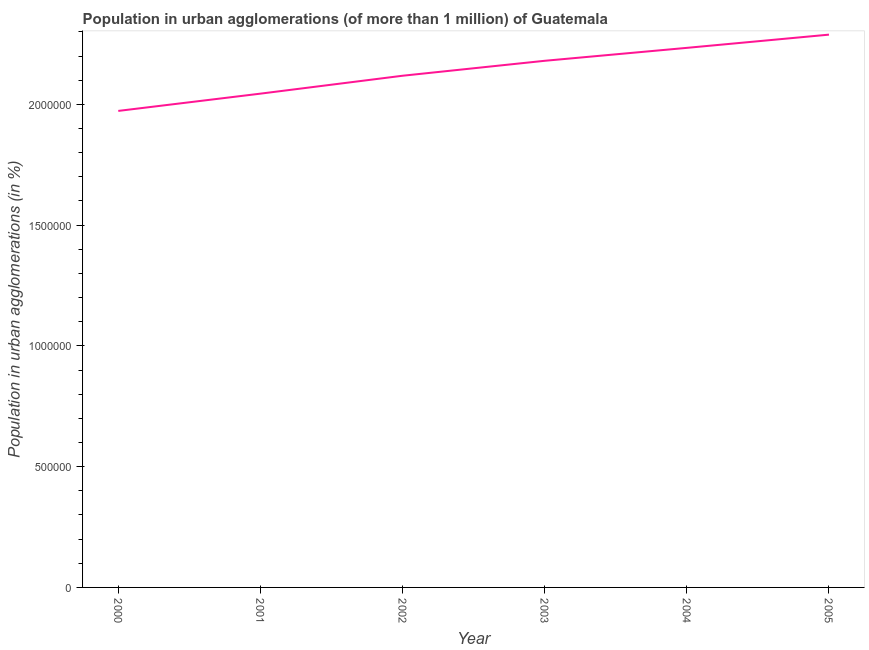What is the population in urban agglomerations in 2001?
Provide a succinct answer. 2.04e+06. Across all years, what is the maximum population in urban agglomerations?
Your answer should be very brief. 2.29e+06. Across all years, what is the minimum population in urban agglomerations?
Provide a short and direct response. 1.97e+06. In which year was the population in urban agglomerations maximum?
Ensure brevity in your answer.  2005. In which year was the population in urban agglomerations minimum?
Keep it short and to the point. 2000. What is the sum of the population in urban agglomerations?
Ensure brevity in your answer.  1.28e+07. What is the difference between the population in urban agglomerations in 2000 and 2004?
Give a very brief answer. -2.61e+05. What is the average population in urban agglomerations per year?
Your answer should be very brief. 2.14e+06. What is the median population in urban agglomerations?
Offer a very short reply. 2.15e+06. What is the ratio of the population in urban agglomerations in 2000 to that in 2004?
Offer a very short reply. 0.88. What is the difference between the highest and the second highest population in urban agglomerations?
Keep it short and to the point. 5.47e+04. Is the sum of the population in urban agglomerations in 2000 and 2001 greater than the maximum population in urban agglomerations across all years?
Offer a terse response. Yes. What is the difference between the highest and the lowest population in urban agglomerations?
Make the answer very short. 3.16e+05. In how many years, is the population in urban agglomerations greater than the average population in urban agglomerations taken over all years?
Offer a terse response. 3. How many lines are there?
Your answer should be compact. 1. How many years are there in the graph?
Your answer should be compact. 6. Does the graph contain any zero values?
Provide a short and direct response. No. Does the graph contain grids?
Give a very brief answer. No. What is the title of the graph?
Offer a terse response. Population in urban agglomerations (of more than 1 million) of Guatemala. What is the label or title of the Y-axis?
Your answer should be compact. Population in urban agglomerations (in %). What is the Population in urban agglomerations (in %) of 2000?
Your answer should be compact. 1.97e+06. What is the Population in urban agglomerations (in %) of 2001?
Make the answer very short. 2.04e+06. What is the Population in urban agglomerations (in %) in 2002?
Offer a very short reply. 2.12e+06. What is the Population in urban agglomerations (in %) in 2003?
Provide a succinct answer. 2.18e+06. What is the Population in urban agglomerations (in %) of 2004?
Your answer should be very brief. 2.23e+06. What is the Population in urban agglomerations (in %) of 2005?
Provide a succinct answer. 2.29e+06. What is the difference between the Population in urban agglomerations (in %) in 2000 and 2001?
Offer a terse response. -7.15e+04. What is the difference between the Population in urban agglomerations (in %) in 2000 and 2002?
Make the answer very short. -1.46e+05. What is the difference between the Population in urban agglomerations (in %) in 2000 and 2003?
Provide a succinct answer. -2.07e+05. What is the difference between the Population in urban agglomerations (in %) in 2000 and 2004?
Ensure brevity in your answer.  -2.61e+05. What is the difference between the Population in urban agglomerations (in %) in 2000 and 2005?
Provide a succinct answer. -3.16e+05. What is the difference between the Population in urban agglomerations (in %) in 2001 and 2002?
Give a very brief answer. -7.41e+04. What is the difference between the Population in urban agglomerations (in %) in 2001 and 2003?
Your answer should be very brief. -1.36e+05. What is the difference between the Population in urban agglomerations (in %) in 2001 and 2004?
Provide a succinct answer. -1.90e+05. What is the difference between the Population in urban agglomerations (in %) in 2001 and 2005?
Ensure brevity in your answer.  -2.44e+05. What is the difference between the Population in urban agglomerations (in %) in 2002 and 2003?
Your answer should be very brief. -6.19e+04. What is the difference between the Population in urban agglomerations (in %) in 2002 and 2004?
Your answer should be very brief. -1.15e+05. What is the difference between the Population in urban agglomerations (in %) in 2002 and 2005?
Make the answer very short. -1.70e+05. What is the difference between the Population in urban agglomerations (in %) in 2003 and 2004?
Provide a succinct answer. -5.36e+04. What is the difference between the Population in urban agglomerations (in %) in 2003 and 2005?
Ensure brevity in your answer.  -1.08e+05. What is the difference between the Population in urban agglomerations (in %) in 2004 and 2005?
Make the answer very short. -5.47e+04. What is the ratio of the Population in urban agglomerations (in %) in 2000 to that in 2003?
Provide a short and direct response. 0.91. What is the ratio of the Population in urban agglomerations (in %) in 2000 to that in 2004?
Provide a succinct answer. 0.88. What is the ratio of the Population in urban agglomerations (in %) in 2000 to that in 2005?
Your answer should be very brief. 0.86. What is the ratio of the Population in urban agglomerations (in %) in 2001 to that in 2002?
Offer a very short reply. 0.96. What is the ratio of the Population in urban agglomerations (in %) in 2001 to that in 2003?
Offer a very short reply. 0.94. What is the ratio of the Population in urban agglomerations (in %) in 2001 to that in 2004?
Ensure brevity in your answer.  0.92. What is the ratio of the Population in urban agglomerations (in %) in 2001 to that in 2005?
Provide a short and direct response. 0.89. What is the ratio of the Population in urban agglomerations (in %) in 2002 to that in 2004?
Ensure brevity in your answer.  0.95. What is the ratio of the Population in urban agglomerations (in %) in 2002 to that in 2005?
Your answer should be compact. 0.93. What is the ratio of the Population in urban agglomerations (in %) in 2003 to that in 2004?
Provide a succinct answer. 0.98. What is the ratio of the Population in urban agglomerations (in %) in 2003 to that in 2005?
Keep it short and to the point. 0.95. 